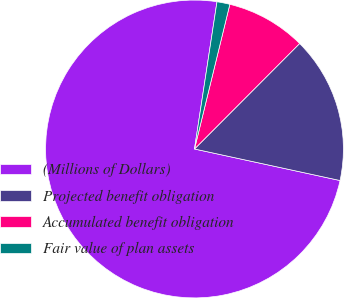Convert chart. <chart><loc_0><loc_0><loc_500><loc_500><pie_chart><fcel>(Millions of Dollars)<fcel>Projected benefit obligation<fcel>Accumulated benefit obligation<fcel>Fair value of plan assets<nl><fcel>74.01%<fcel>15.92%<fcel>8.66%<fcel>1.4%<nl></chart> 